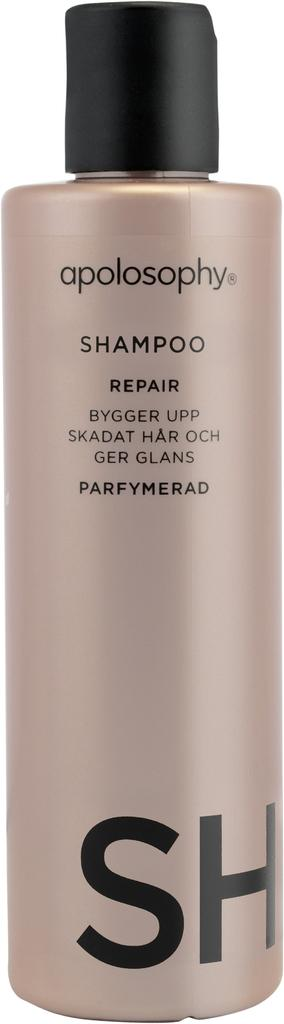<image>
Provide a brief description of the given image. A bottle of apolosophy repair shampoo with a black cap. 